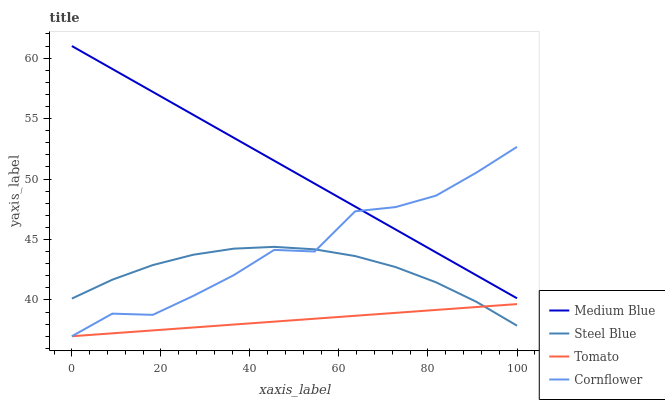Does Tomato have the minimum area under the curve?
Answer yes or no. Yes. Does Medium Blue have the maximum area under the curve?
Answer yes or no. Yes. Does Cornflower have the minimum area under the curve?
Answer yes or no. No. Does Cornflower have the maximum area under the curve?
Answer yes or no. No. Is Tomato the smoothest?
Answer yes or no. Yes. Is Cornflower the roughest?
Answer yes or no. Yes. Is Medium Blue the smoothest?
Answer yes or no. No. Is Medium Blue the roughest?
Answer yes or no. No. Does Tomato have the lowest value?
Answer yes or no. Yes. Does Medium Blue have the lowest value?
Answer yes or no. No. Does Medium Blue have the highest value?
Answer yes or no. Yes. Does Cornflower have the highest value?
Answer yes or no. No. Is Steel Blue less than Medium Blue?
Answer yes or no. Yes. Is Medium Blue greater than Steel Blue?
Answer yes or no. Yes. Does Cornflower intersect Medium Blue?
Answer yes or no. Yes. Is Cornflower less than Medium Blue?
Answer yes or no. No. Is Cornflower greater than Medium Blue?
Answer yes or no. No. Does Steel Blue intersect Medium Blue?
Answer yes or no. No. 